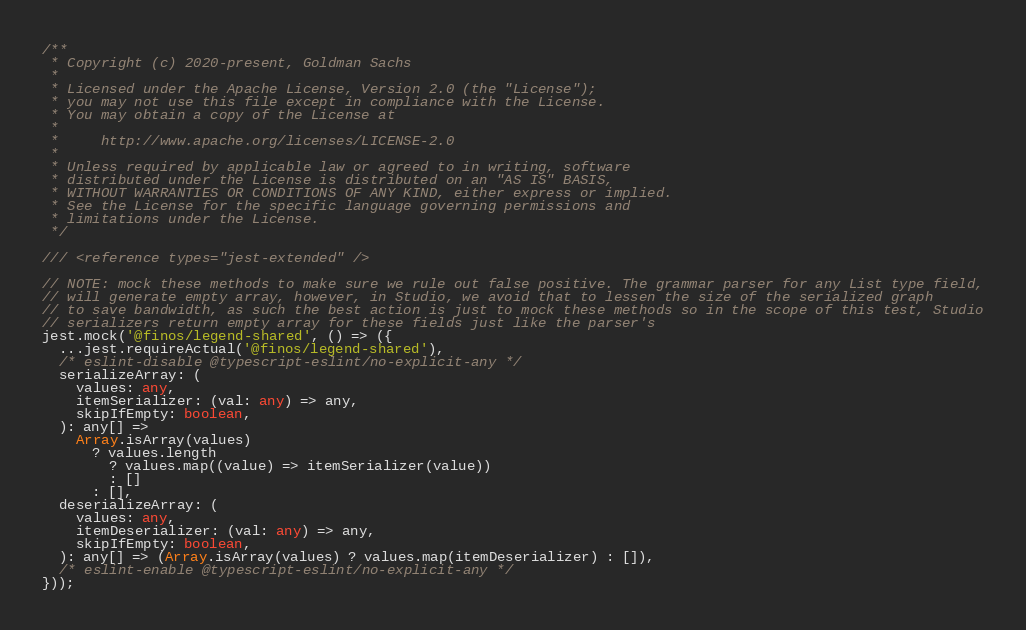Convert code to text. <code><loc_0><loc_0><loc_500><loc_500><_TypeScript_>/**
 * Copyright (c) 2020-present, Goldman Sachs
 *
 * Licensed under the Apache License, Version 2.0 (the "License");
 * you may not use this file except in compliance with the License.
 * You may obtain a copy of the License at
 *
 *     http://www.apache.org/licenses/LICENSE-2.0
 *
 * Unless required by applicable law or agreed to in writing, software
 * distributed under the License is distributed on an "AS IS" BASIS,
 * WITHOUT WARRANTIES OR CONDITIONS OF ANY KIND, either express or implied.
 * See the License for the specific language governing permissions and
 * limitations under the License.
 */

/// <reference types="jest-extended" />

// NOTE: mock these methods to make sure we rule out false positive. The grammar parser for any List type field,
// will generate empty array, however, in Studio, we avoid that to lessen the size of the serialized graph
// to save bandwidth, as such the best action is just to mock these methods so in the scope of this test, Studio
// serializers return empty array for these fields just like the parser's
jest.mock('@finos/legend-shared', () => ({
  ...jest.requireActual('@finos/legend-shared'),
  /* eslint-disable @typescript-eslint/no-explicit-any */
  serializeArray: (
    values: any,
    itemSerializer: (val: any) => any,
    skipIfEmpty: boolean,
  ): any[] =>
    Array.isArray(values)
      ? values.length
        ? values.map((value) => itemSerializer(value))
        : []
      : [],
  deserializeArray: (
    values: any,
    itemDeserializer: (val: any) => any,
    skipIfEmpty: boolean,
  ): any[] => (Array.isArray(values) ? values.map(itemDeserializer) : []),
  /* eslint-enable @typescript-eslint/no-explicit-any */
}));
</code> 